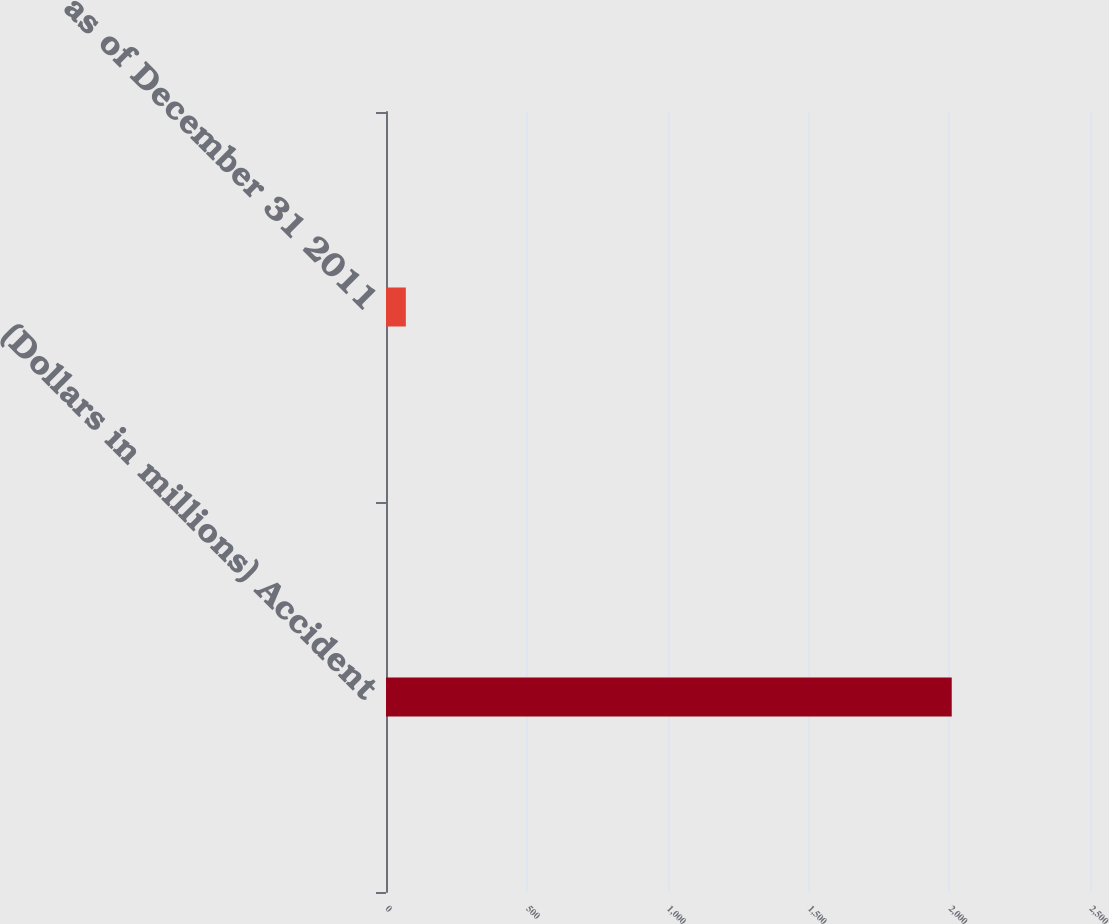Convert chart to OTSL. <chart><loc_0><loc_0><loc_500><loc_500><bar_chart><fcel>(Dollars in millions) Accident<fcel>as of December 31 2011<nl><fcel>2009<fcel>70.4<nl></chart> 